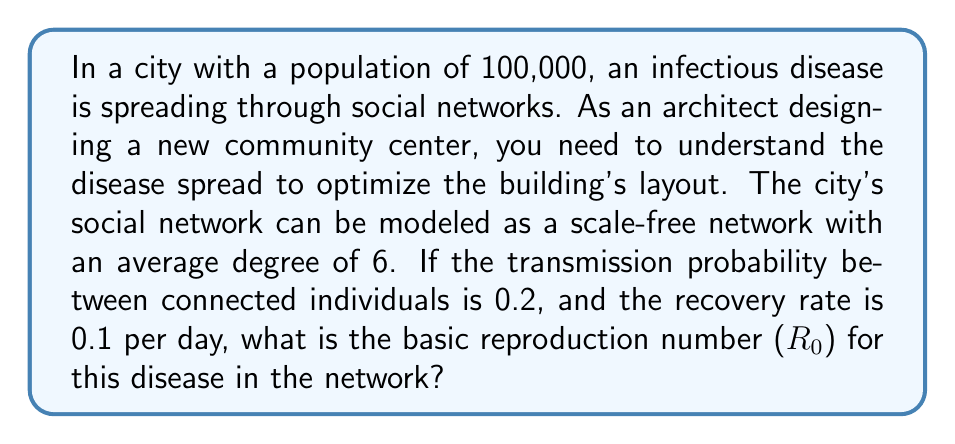Show me your answer to this math problem. To solve this problem, we need to use concepts from network theory and epidemiology. The basic reproduction number ($R_0$) in a network model is influenced by the network structure and disease parameters.

1. In a scale-free network, the degree distribution follows a power law. The average degree ($\langle k \rangle$) is given as 6.

2. The transmission probability ($\beta$) between connected individuals is 0.2.

3. The recovery rate ($\gamma$) is 0.1 per day.

4. For a scale-free network, the basic reproduction number is given by the formula:

   $$R_0 = \frac{\beta}{\gamma} \cdot \frac{\langle k^2 \rangle}{\langle k \rangle}$$

   Where $\langle k^2 \rangle$ is the second moment of the degree distribution.

5. For scale-free networks, the ratio $\frac{\langle k^2 \rangle}{\langle k \rangle}$ is typically much larger than the average degree $\langle k \rangle$. A common approximation is:

   $$\frac{\langle k^2 \rangle}{\langle k \rangle} \approx \langle k \rangle \cdot \ln N$$

   Where $N$ is the network size (population).

6. Substituting the values:

   $$R_0 = \frac{0.2}{0.1} \cdot 6 \cdot \ln(100,000)$$

7. Calculating:
   $$R_0 = 2 \cdot 6 \cdot \ln(100,000) \approx 2 \cdot 6 \cdot 11.51 \approx 138.12$$

Thus, the basic reproduction number for this disease in the given network is approximately 138.12.
Answer: $R_0 \approx 138.12$ 